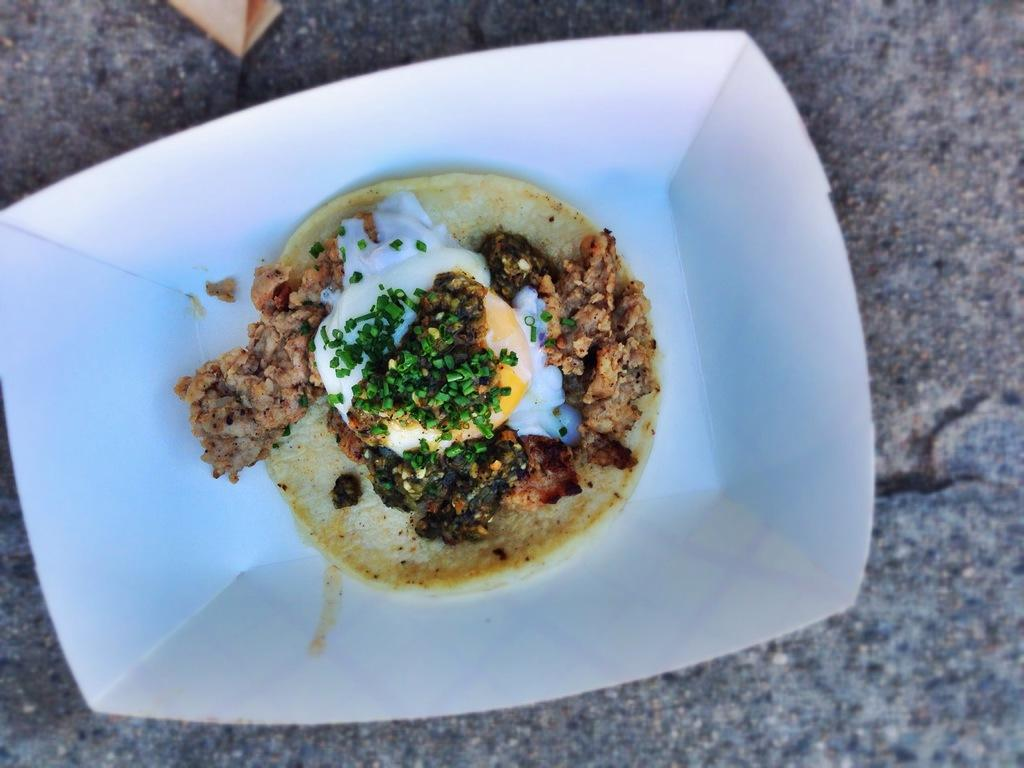What is on the plate that is visible in the image? There is a plate with food in the image. What color is the plate? The plate is white. What colors can be seen in the food on the plate? The food has green, brown, white, and cream colors. What is the color of the surface the plate is on? The plate is on an ash-colored surface. What type of jewel is being used to conduct electricity in the image? There is no jewel present in the image, and therefore no such activity can be observed. 